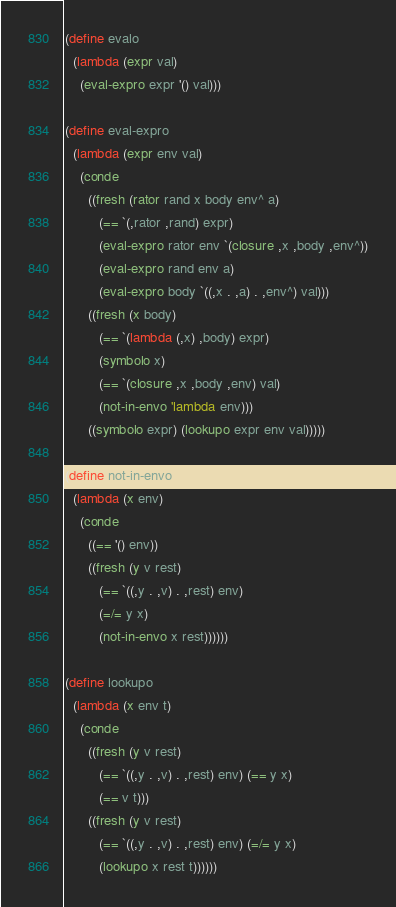<code> <loc_0><loc_0><loc_500><loc_500><_Scheme_>(define evalo
  (lambda (expr val)
    (eval-expro expr '() val)))

(define eval-expro
  (lambda (expr env val)
    (conde
      ((fresh (rator rand x body env^ a)
         (== `(,rator ,rand) expr)
         (eval-expro rator env `(closure ,x ,body ,env^))
         (eval-expro rand env a)
         (eval-expro body `((,x . ,a) . ,env^) val)))
      ((fresh (x body)
         (== `(lambda (,x) ,body) expr)
         (symbolo x)
         (== `(closure ,x ,body ,env) val)
         (not-in-envo 'lambda env)))
      ((symbolo expr) (lookupo expr env val)))))

(define not-in-envo
  (lambda (x env)
    (conde
      ((== '() env))
      ((fresh (y v rest)
         (== `((,y . ,v) . ,rest) env)
         (=/= y x)
         (not-in-envo x rest))))))

(define lookupo
  (lambda (x env t)
    (conde
      ((fresh (y v rest)
         (== `((,y . ,v) . ,rest) env) (== y x)
         (== v t)))
      ((fresh (y v rest)
         (== `((,y . ,v) . ,rest) env) (=/= y x)
         (lookupo x rest t))))))
</code> 